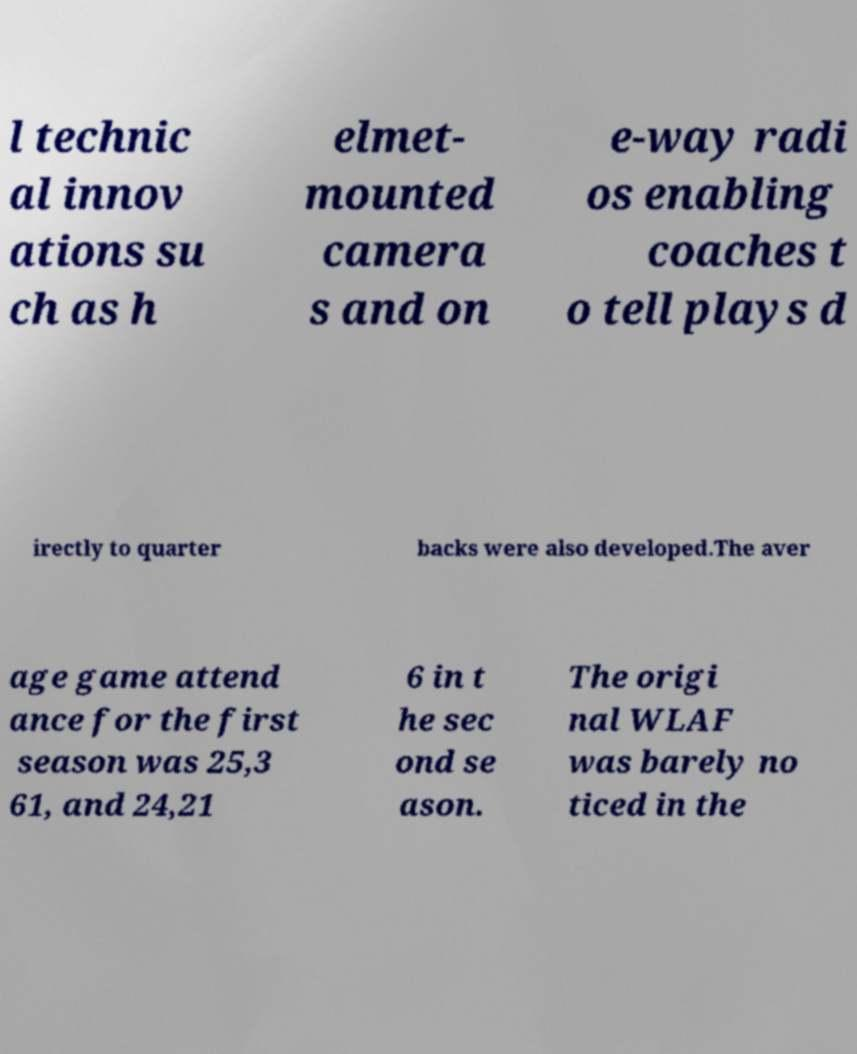Can you read and provide the text displayed in the image?This photo seems to have some interesting text. Can you extract and type it out for me? l technic al innov ations su ch as h elmet- mounted camera s and on e-way radi os enabling coaches t o tell plays d irectly to quarter backs were also developed.The aver age game attend ance for the first season was 25,3 61, and 24,21 6 in t he sec ond se ason. The origi nal WLAF was barely no ticed in the 